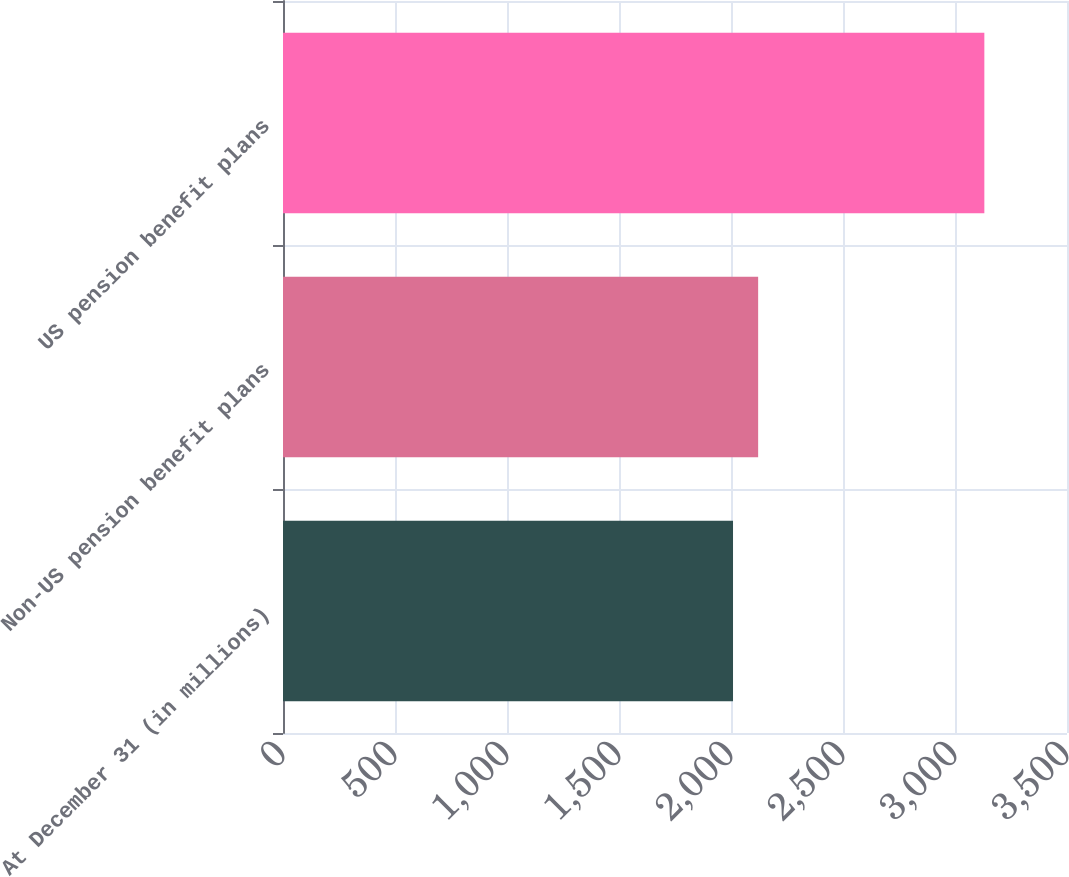<chart> <loc_0><loc_0><loc_500><loc_500><bar_chart><fcel>At December 31 (in millions)<fcel>Non-US pension benefit plans<fcel>US pension benefit plans<nl><fcel>2009<fcel>2121.2<fcel>3131<nl></chart> 